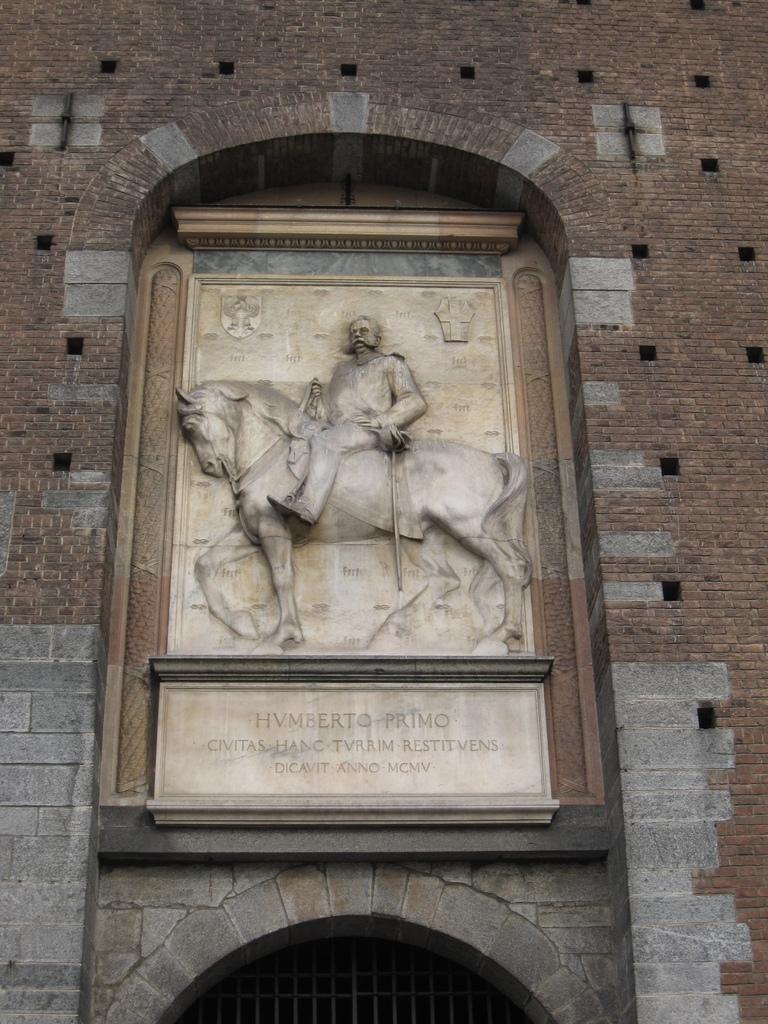How would you summarize this image in a sentence or two? In this image, in the middle we can see a statue of a man and a horse and we can see there are many bricks on the left side and on the right side and at the bottom we can see many iron rods. 